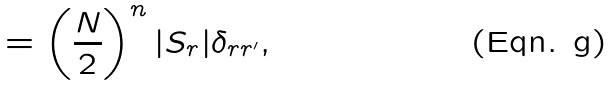Convert formula to latex. <formula><loc_0><loc_0><loc_500><loc_500>= \left ( \frac { N } { 2 } \right ) ^ { n } | S _ { r } | \delta _ { { r } { r } ^ { \prime } } ,</formula> 